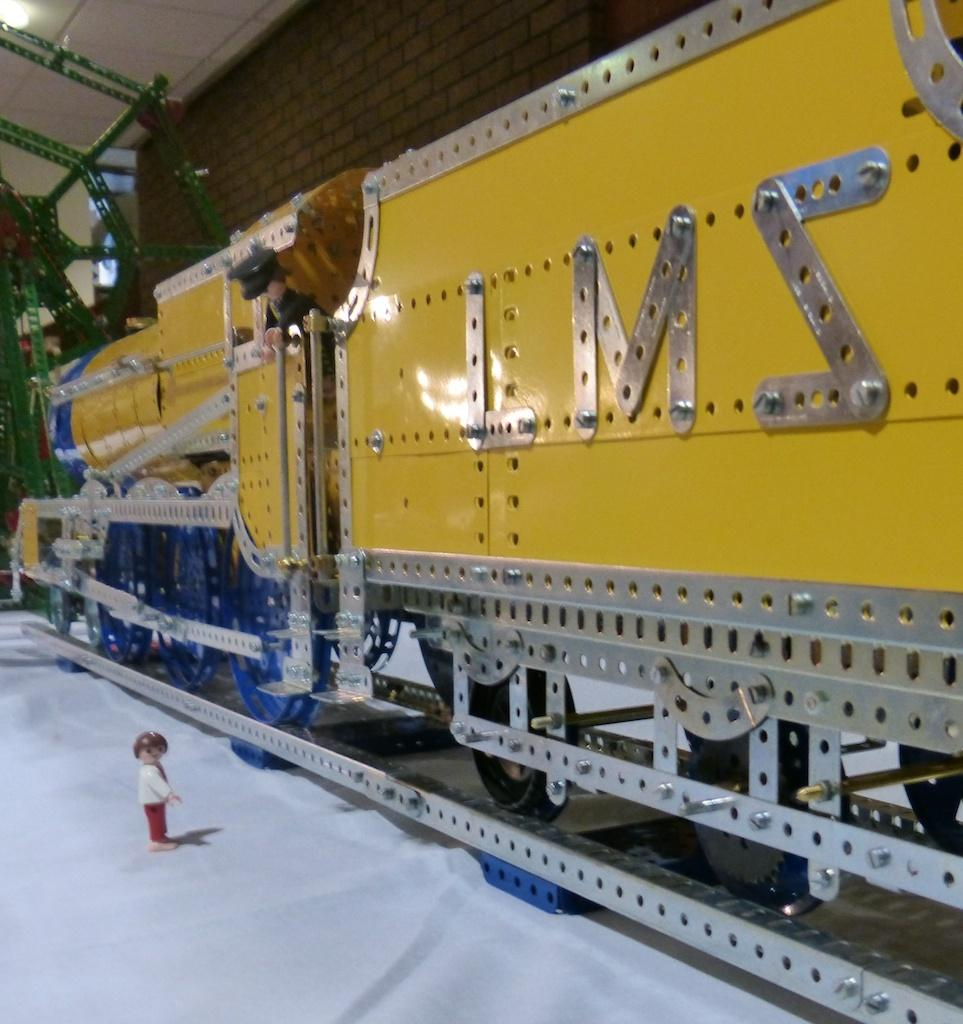<image>
Summarize the visual content of the image. A yellow and blue Meccano train with LMS on the side is on display. 